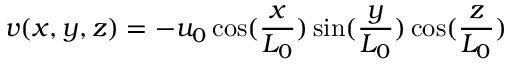Convert formula to latex. <formula><loc_0><loc_0><loc_500><loc_500>v ( x , y , z ) = - u _ { 0 } \cos ( \frac { x } { L _ { 0 } } ) \sin ( \frac { y } { L _ { 0 } } ) \cos ( \frac { z } { L _ { 0 } } )</formula> 